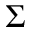<formula> <loc_0><loc_0><loc_500><loc_500>\Sigma</formula> 